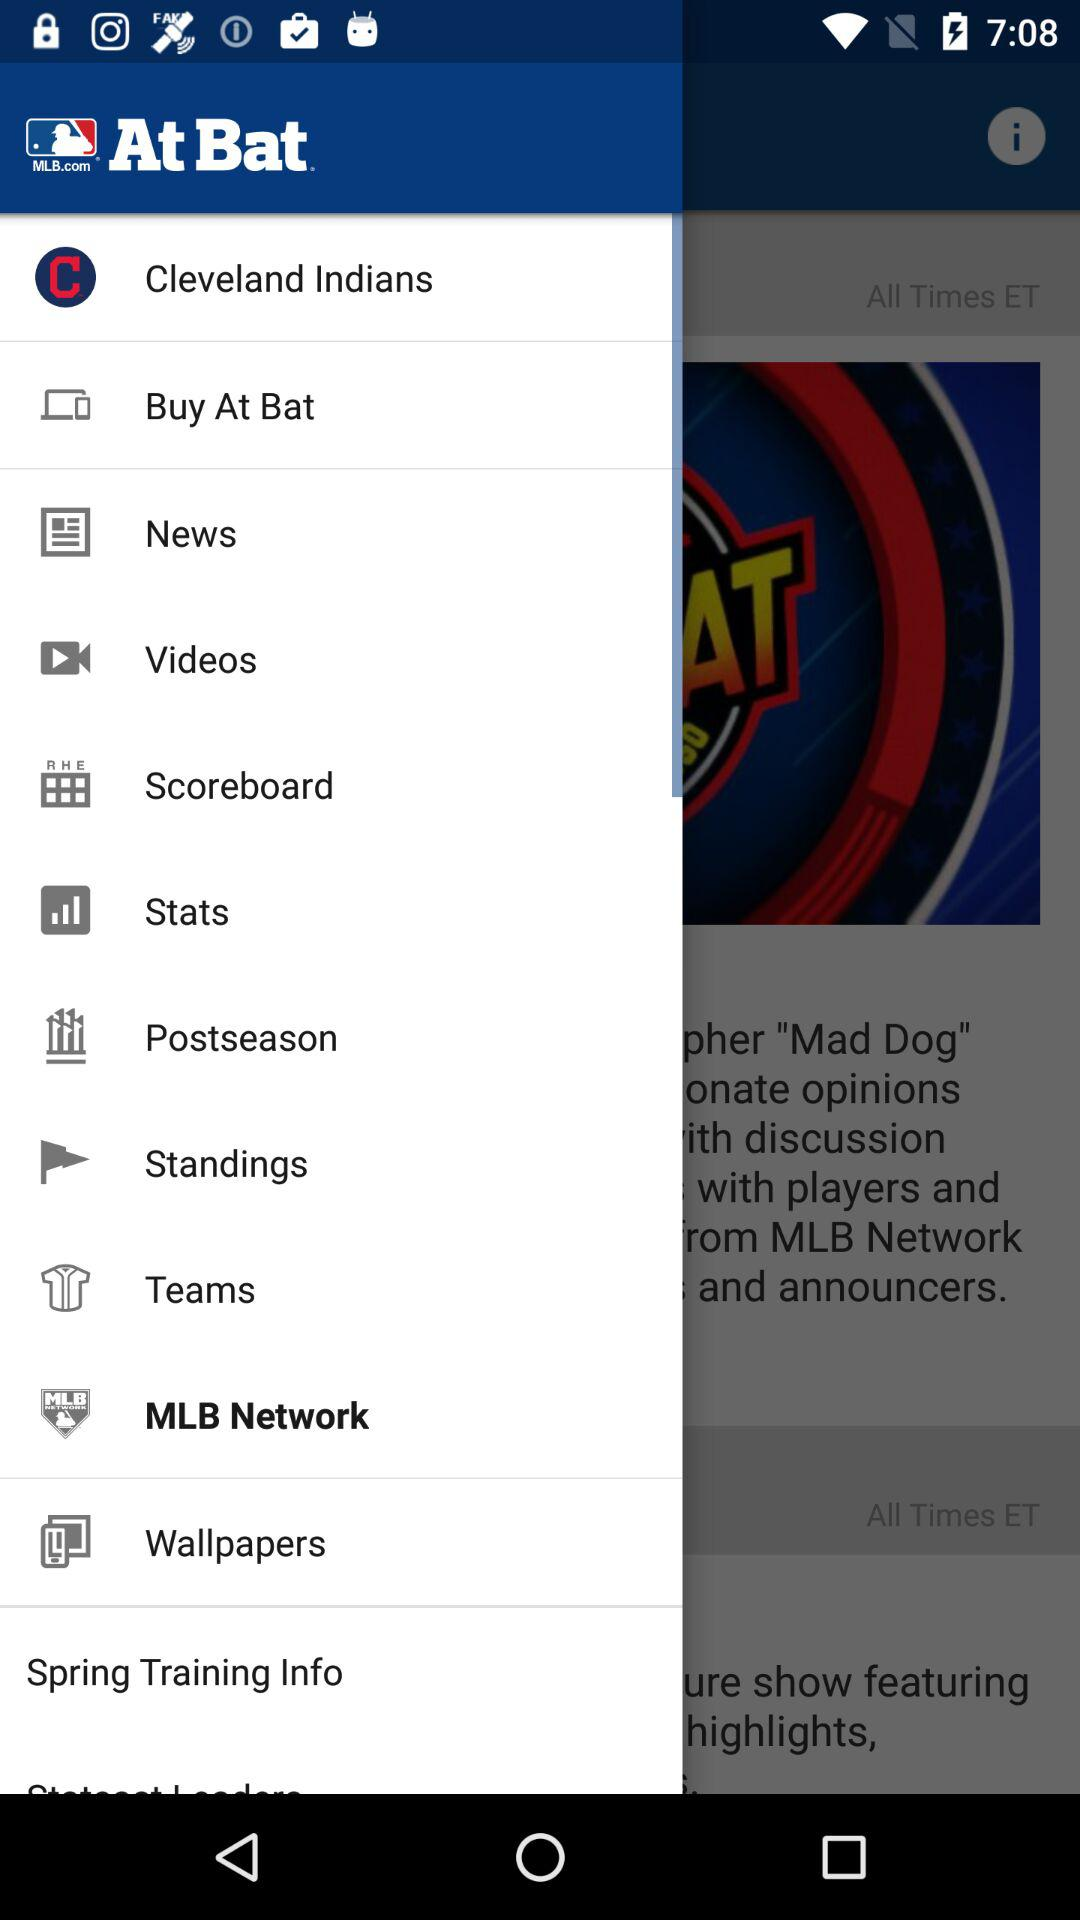Which item is selected? The selected item is "MLB Network". 